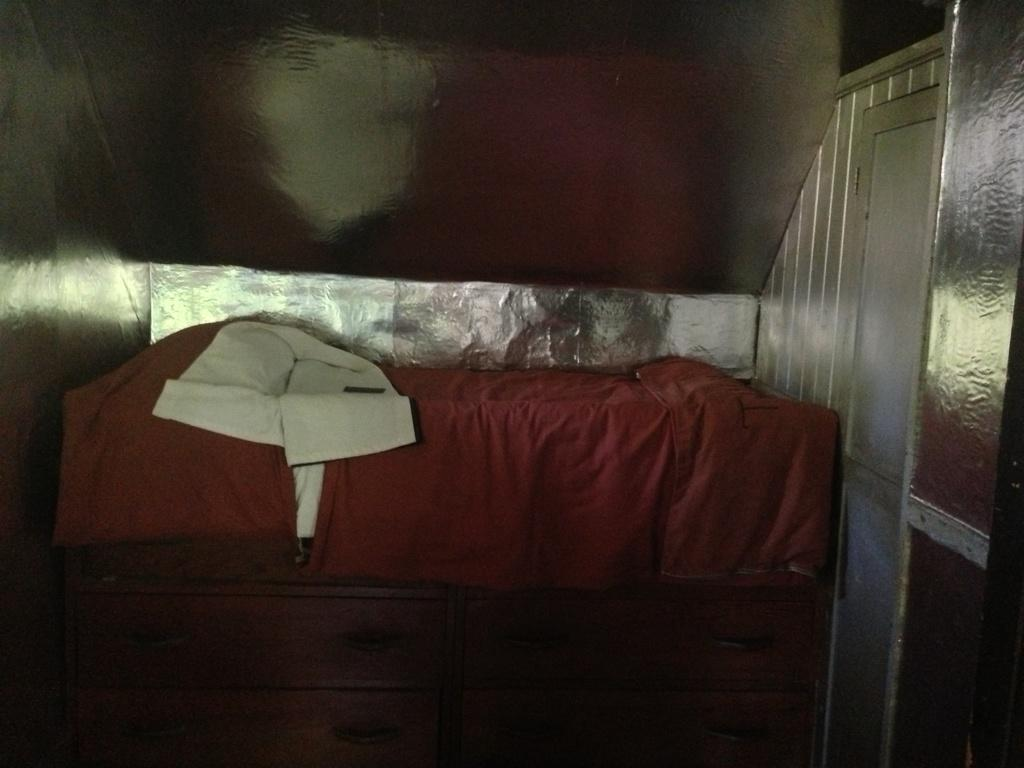What piece of furniture is present in the picture? There is a bed in the picture. What color is the blanket on the bed? The bed has a red color blanket on it. Where is the door located in the picture? The door is on the right side of the picture. What type of steam can be seen coming from the bed in the picture? There is no steam present in the picture; it features a bed with a red color blanket and a door on the right side. 